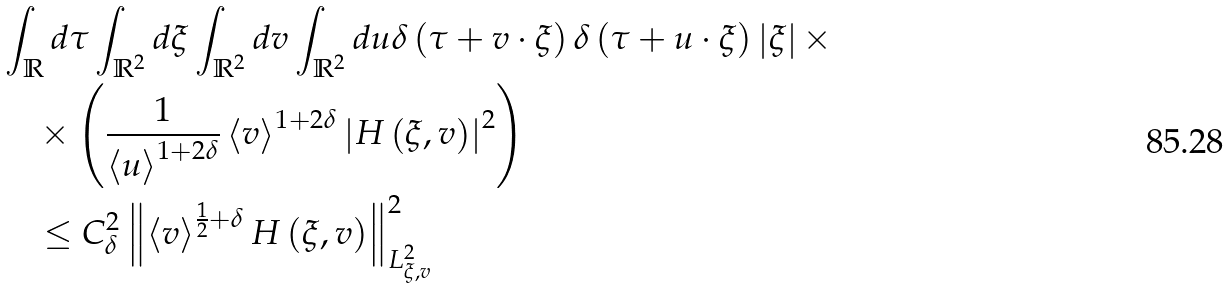<formula> <loc_0><loc_0><loc_500><loc_500>& \int _ { \mathbb { R } } d \tau \int _ { \mathbb { R } ^ { 2 } } d \xi \int _ { \mathbb { R } ^ { 2 } } d v \int _ { \mathbb { R } ^ { 2 } } d u \delta \left ( \tau + v \cdot \xi \right ) \delta \left ( \tau + u \cdot \xi \right ) \left | \xi \right | \times \\ & \quad \times \left ( \frac { 1 } { \left < u \right > ^ { 1 + 2 \delta } } \left < v \right > ^ { 1 + 2 \delta } \left | H \left ( \xi , v \right ) \right | ^ { 2 } \right ) \\ & \quad \leq C _ { \delta } ^ { 2 } \left \| \left < v \right > ^ { \frac { 1 } { 2 } + \delta } H \left ( \xi , v \right ) \right \| _ { L ^ { 2 } _ { \xi , v } } ^ { 2 }</formula> 